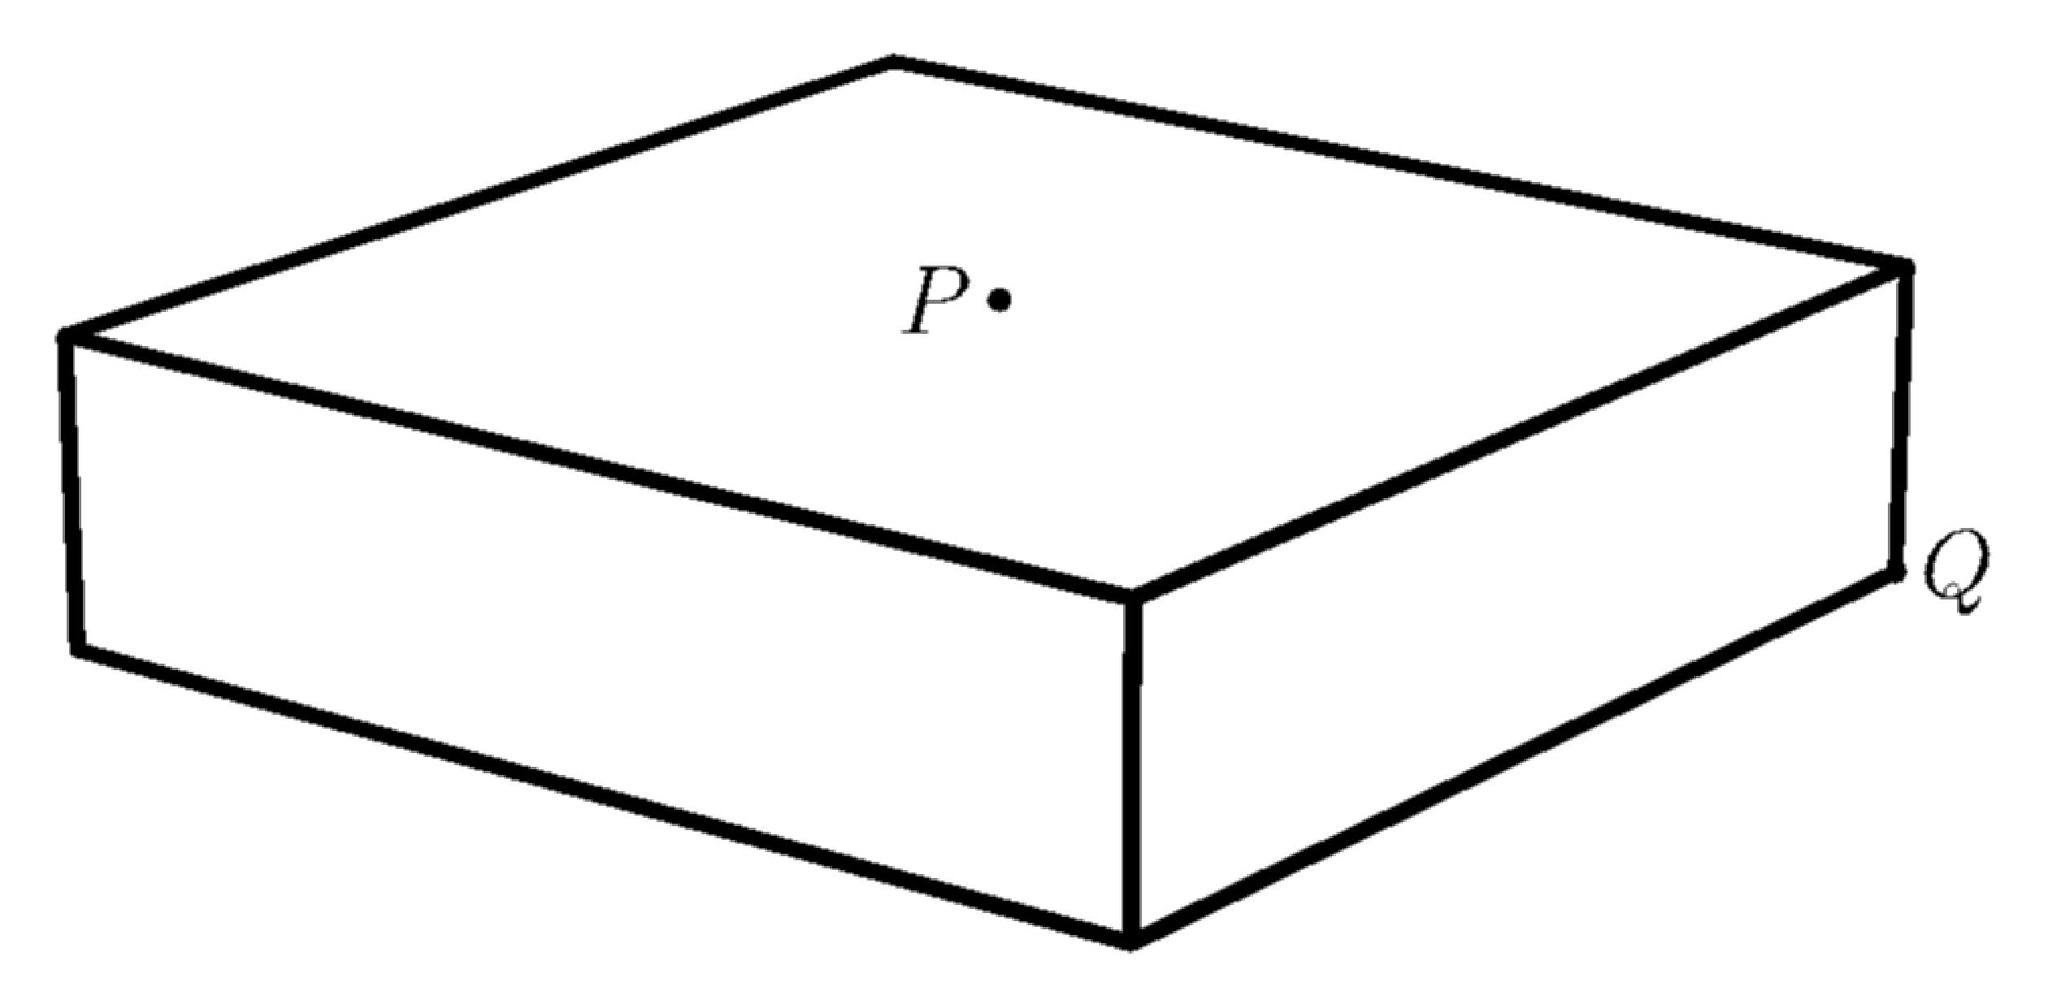Can you explain how the calculations for distances in a 3D shape like this box differs from calculating distances in a 2D shape? Absolutely! In a 2D shape, distances are calculated using the Pythagorean theorem for the plane, considering only two dimensions. For a 3D shape like this box, we must consider the additional depth (or height), which means extending the Pythagorean theorem to include a third dimension. Essentially, it's like calculating the diagonal not just on the surface (the base of the box here), but through the space inside the box. 